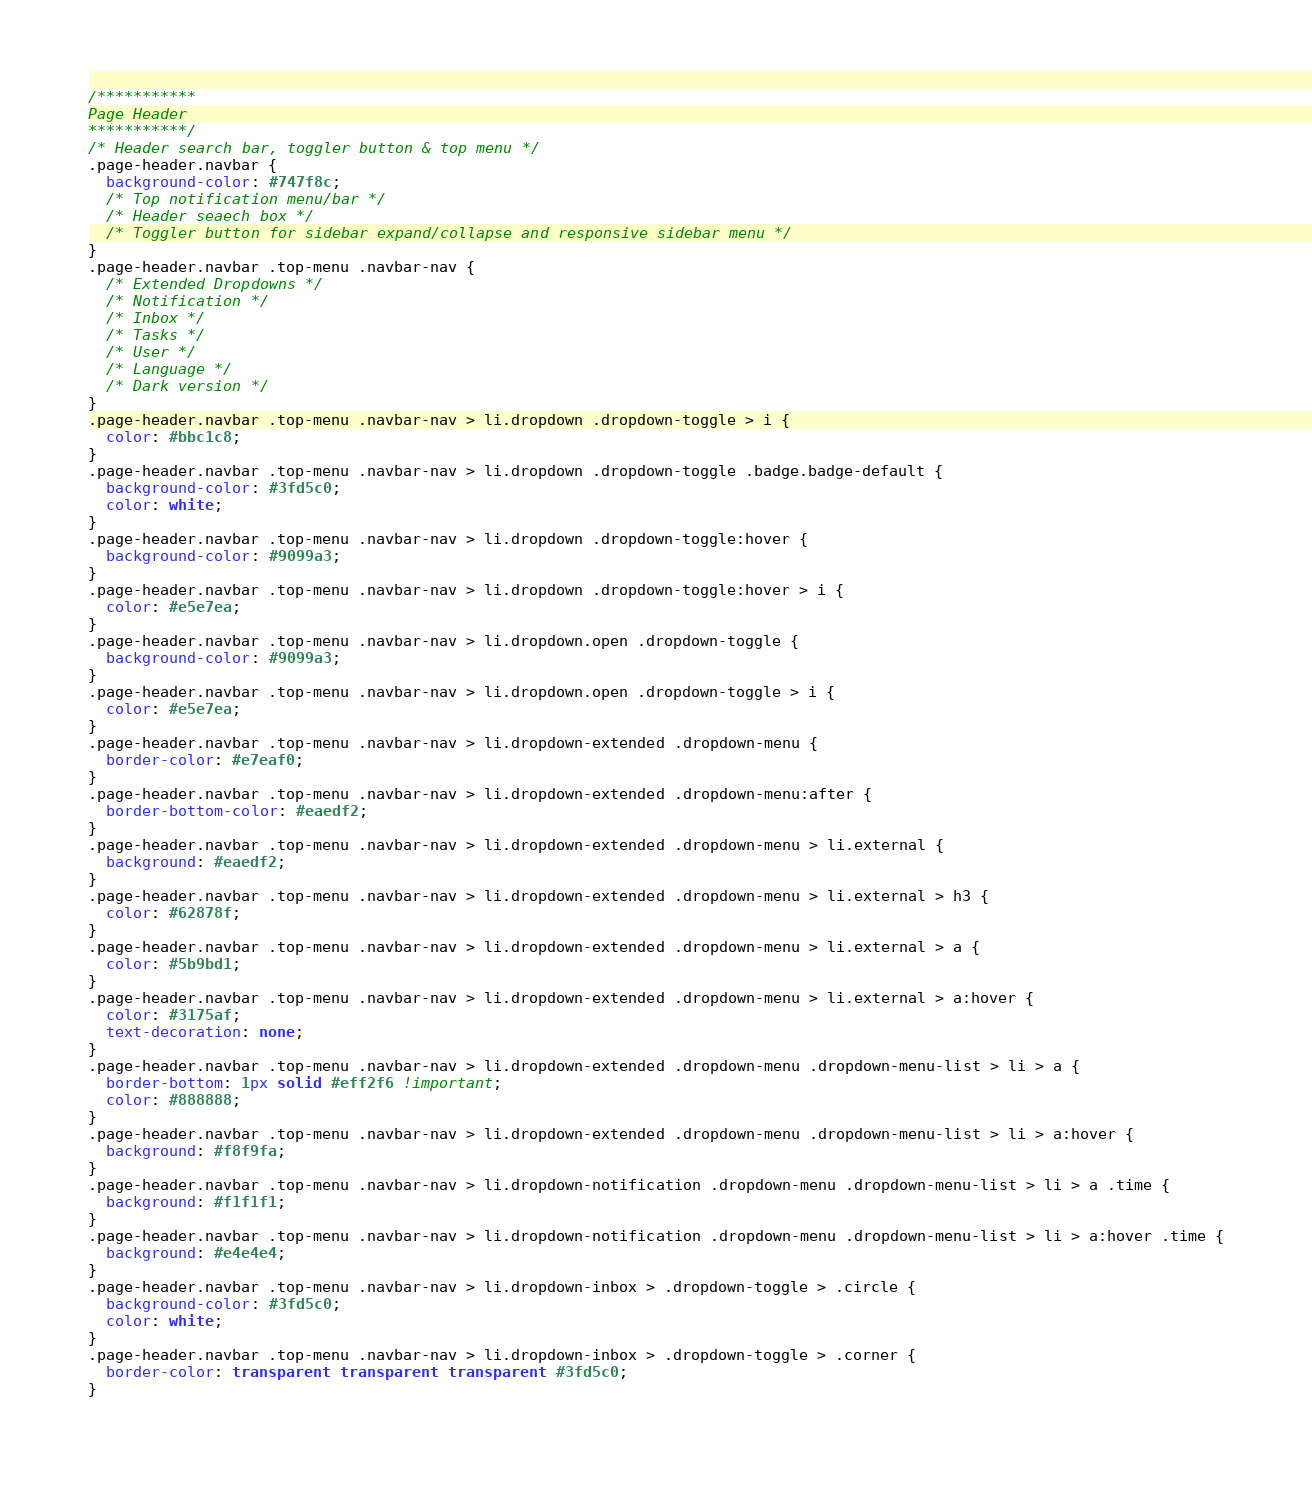<code> <loc_0><loc_0><loc_500><loc_500><_CSS_>/*********** 
Page Header
***********/
/* Header search bar, toggler button & top menu */
.page-header.navbar {
  background-color: #747f8c;
  /* Top notification menu/bar */
  /* Header seaech box */
  /* Toggler button for sidebar expand/collapse and responsive sidebar menu */
}
.page-header.navbar .top-menu .navbar-nav {
  /* Extended Dropdowns */
  /* Notification */
  /* Inbox */
  /* Tasks */
  /* User */
  /* Language */
  /* Dark version */
}
.page-header.navbar .top-menu .navbar-nav > li.dropdown .dropdown-toggle > i {
  color: #bbc1c8;
}
.page-header.navbar .top-menu .navbar-nav > li.dropdown .dropdown-toggle .badge.badge-default {
  background-color: #3fd5c0;
  color: white;
}
.page-header.navbar .top-menu .navbar-nav > li.dropdown .dropdown-toggle:hover {
  background-color: #9099a3;
}
.page-header.navbar .top-menu .navbar-nav > li.dropdown .dropdown-toggle:hover > i {
  color: #e5e7ea;
}
.page-header.navbar .top-menu .navbar-nav > li.dropdown.open .dropdown-toggle {
  background-color: #9099a3;
}
.page-header.navbar .top-menu .navbar-nav > li.dropdown.open .dropdown-toggle > i {
  color: #e5e7ea;
}
.page-header.navbar .top-menu .navbar-nav > li.dropdown-extended .dropdown-menu {
  border-color: #e7eaf0;
}
.page-header.navbar .top-menu .navbar-nav > li.dropdown-extended .dropdown-menu:after {
  border-bottom-color: #eaedf2;
}
.page-header.navbar .top-menu .navbar-nav > li.dropdown-extended .dropdown-menu > li.external {
  background: #eaedf2;
}
.page-header.navbar .top-menu .navbar-nav > li.dropdown-extended .dropdown-menu > li.external > h3 {
  color: #62878f;
}
.page-header.navbar .top-menu .navbar-nav > li.dropdown-extended .dropdown-menu > li.external > a {
  color: #5b9bd1;
}
.page-header.navbar .top-menu .navbar-nav > li.dropdown-extended .dropdown-menu > li.external > a:hover {
  color: #3175af;
  text-decoration: none;
}
.page-header.navbar .top-menu .navbar-nav > li.dropdown-extended .dropdown-menu .dropdown-menu-list > li > a {
  border-bottom: 1px solid #eff2f6 !important;
  color: #888888;
}
.page-header.navbar .top-menu .navbar-nav > li.dropdown-extended .dropdown-menu .dropdown-menu-list > li > a:hover {
  background: #f8f9fa;
}
.page-header.navbar .top-menu .navbar-nav > li.dropdown-notification .dropdown-menu .dropdown-menu-list > li > a .time {
  background: #f1f1f1;
}
.page-header.navbar .top-menu .navbar-nav > li.dropdown-notification .dropdown-menu .dropdown-menu-list > li > a:hover .time {
  background: #e4e4e4;
}
.page-header.navbar .top-menu .navbar-nav > li.dropdown-inbox > .dropdown-toggle > .circle {
  background-color: #3fd5c0;
  color: white;
}
.page-header.navbar .top-menu .navbar-nav > li.dropdown-inbox > .dropdown-toggle > .corner {
  border-color: transparent transparent transparent #3fd5c0;
}</code> 